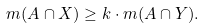Convert formula to latex. <formula><loc_0><loc_0><loc_500><loc_500>m ( A \cap X ) \geq k \cdot m ( A \cap Y ) .</formula> 